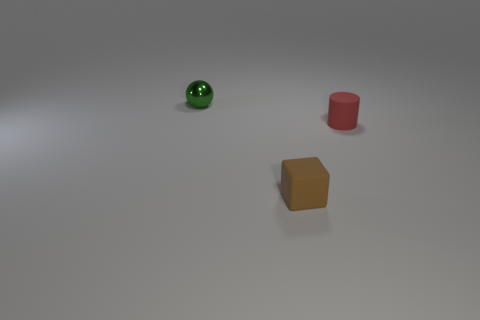Are there fewer yellow shiny cubes than small red cylinders?
Your answer should be compact. Yes. There is a green shiny thing; does it have the same shape as the matte object on the right side of the small brown cube?
Offer a terse response. No. What shape is the thing that is both to the left of the small rubber cylinder and behind the small brown matte block?
Your answer should be compact. Sphere. Are there an equal number of green metal balls that are in front of the metal ball and rubber things on the left side of the tiny red rubber object?
Provide a short and direct response. No. There is a tiny object right of the block; does it have the same shape as the small green object?
Give a very brief answer. No. How many cyan things are either small things or blocks?
Offer a very short reply. 0. The thing that is left of the brown rubber thing has what shape?
Ensure brevity in your answer.  Sphere. Are there any cyan cylinders made of the same material as the brown block?
Give a very brief answer. No. Is the brown rubber block the same size as the metal thing?
Your answer should be very brief. Yes. What number of balls are small matte things or gray rubber things?
Keep it short and to the point. 0. 